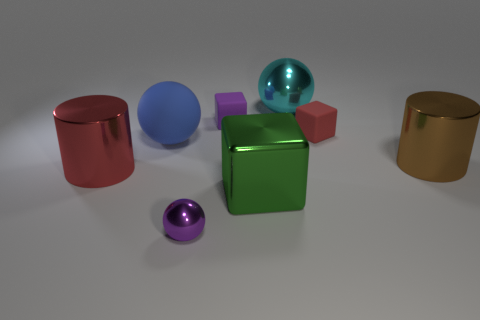Do the small thing right of the purple block and the small purple cube have the same material?
Keep it short and to the point. Yes. Is there a big cyan object on the left side of the blue rubber ball that is behind the metal cylinder that is to the right of the large blue sphere?
Provide a short and direct response. No. What number of blocks are shiny objects or large red shiny things?
Make the answer very short. 1. There is a tiny block that is on the right side of the large shiny sphere; what material is it?
Give a very brief answer. Rubber. There is a thing that is the same color as the small metal ball; what size is it?
Keep it short and to the point. Small. Is the color of the tiny matte block that is left of the green shiny block the same as the tiny rubber cube that is to the right of the green metallic block?
Keep it short and to the point. No. What number of things are either brown matte objects or matte cubes?
Your response must be concise. 2. How many other things are the same shape as the large green object?
Offer a terse response. 2. Is the material of the purple thing that is in front of the big red object the same as the large cylinder to the left of the green metallic cube?
Provide a short and direct response. Yes. There is a small object that is to the left of the red cube and behind the large shiny cube; what is its shape?
Provide a succinct answer. Cube. 